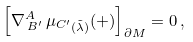Convert formula to latex. <formula><loc_0><loc_0><loc_500><loc_500>\left [ \nabla _ { \, B ^ { \prime } } ^ { A } \, { \mu _ { C ^ { \prime } } } _ { ( \tilde { \lambda } ) } ( + ) \right ] _ { \partial M } = 0 \, ,</formula> 